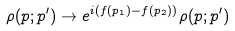Convert formula to latex. <formula><loc_0><loc_0><loc_500><loc_500>\rho ( p ; p ^ { \prime } ) \rightarrow e ^ { i \left ( f ( p _ { 1 } ) - f ( p _ { 2 } ) \right ) } \rho ( p ; p ^ { \prime } )</formula> 